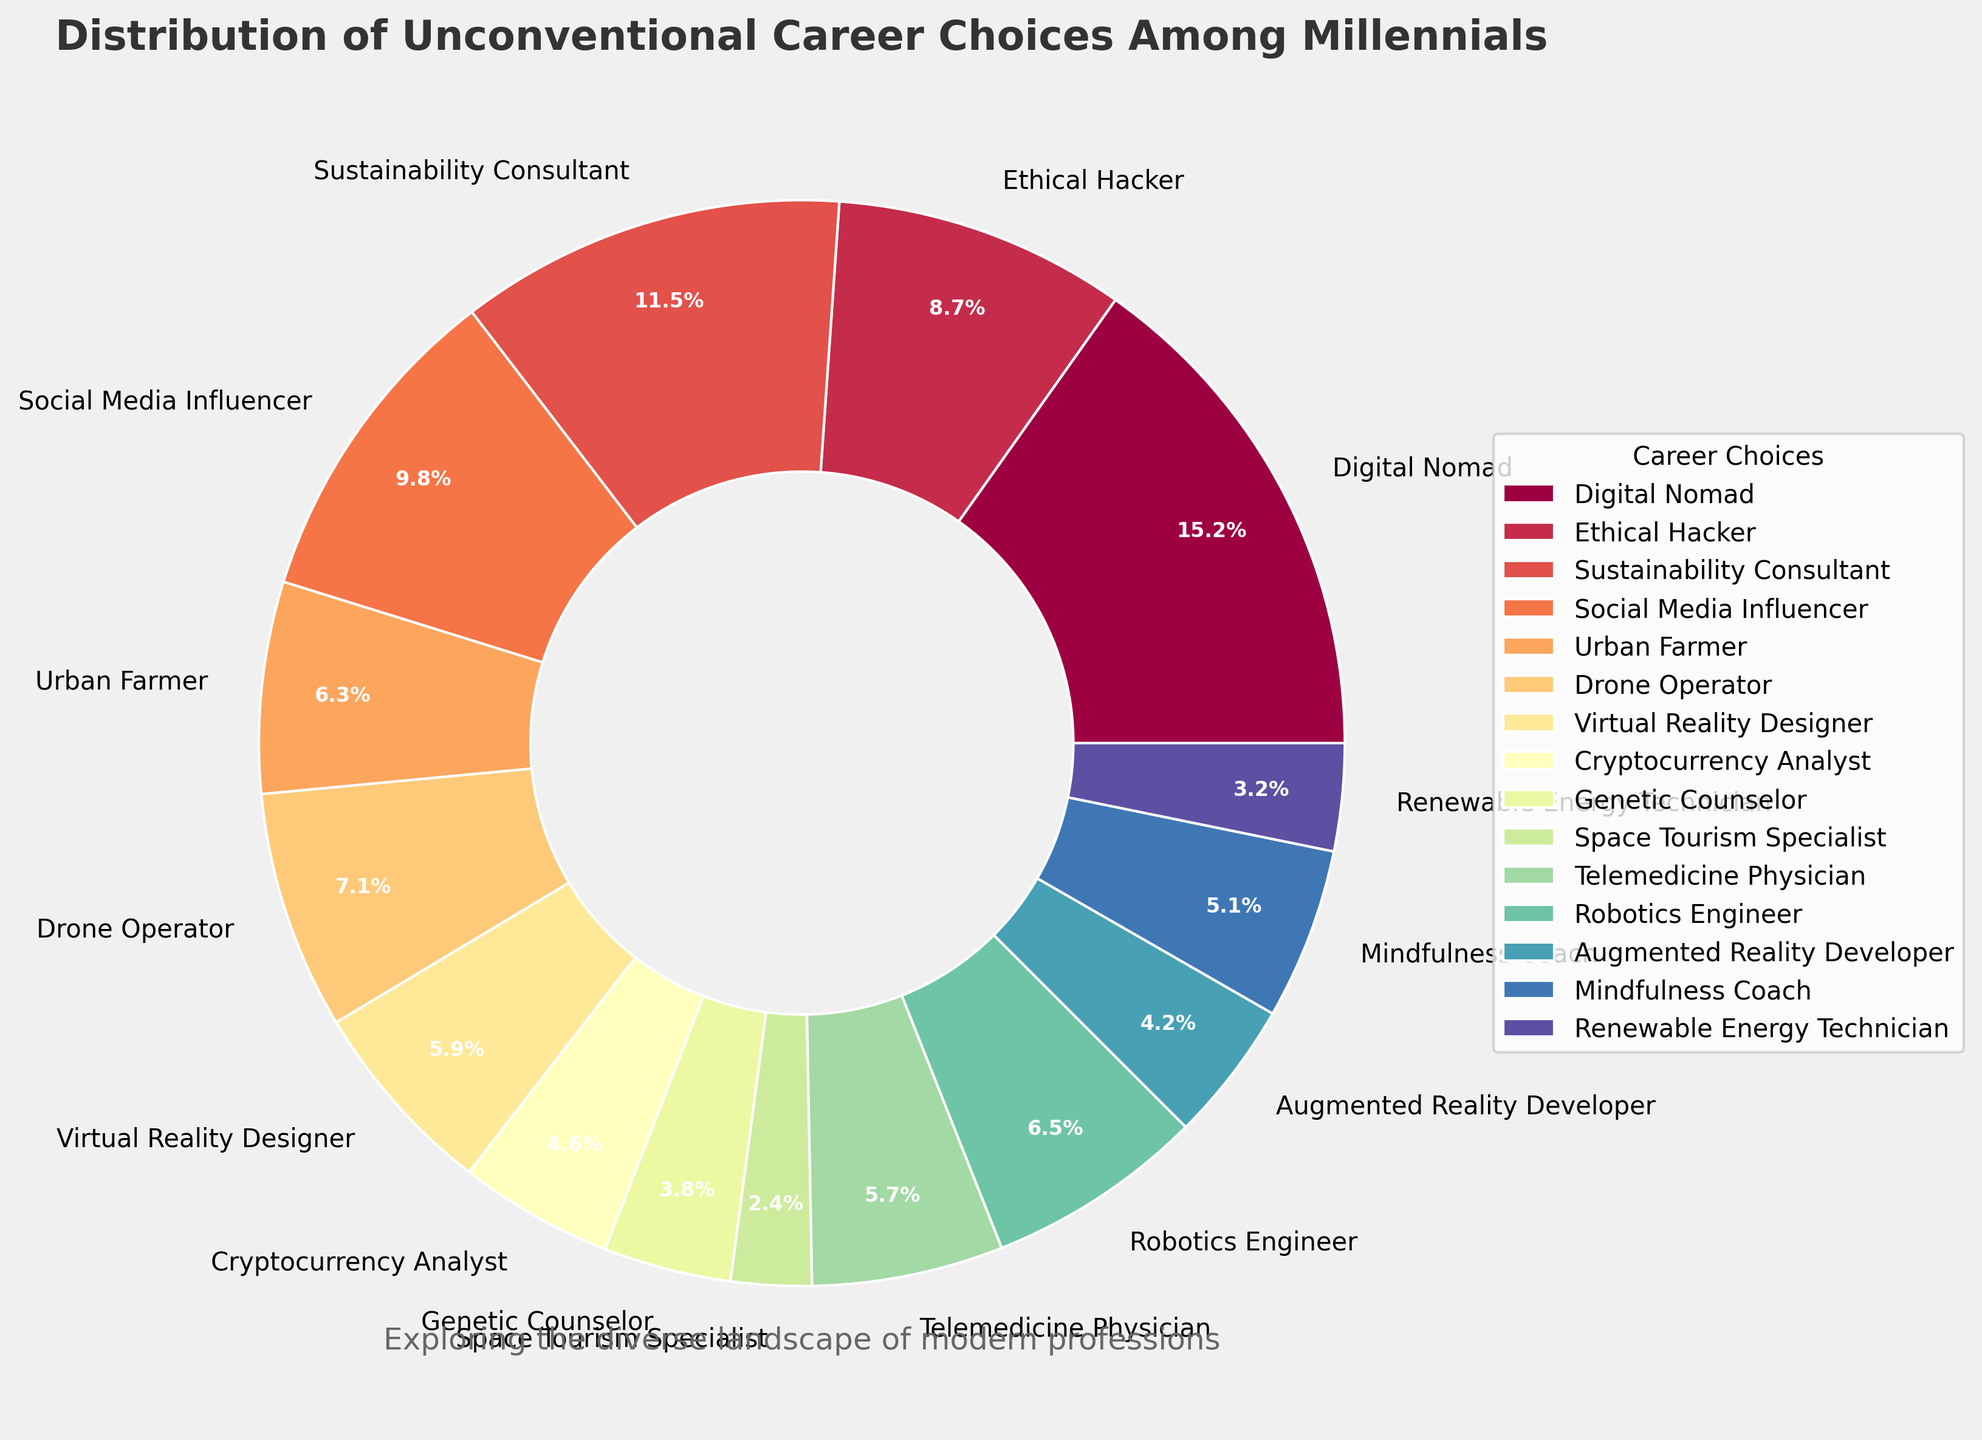Which career has the highest percentage of millennials? The pie chart segments represent the distribution of percentages for the different careers. By looking at the sizes and the labels, we can identify the segment with the largest percentage.
Answer: Digital Nomad How much more popular is being a Digital Nomad compared to a Social Media Influencer? Find the percentages for both careers from the pie chart (Digital Nomad: 15.2%, Social Media Influencer: 9.8%) and subtract the Influencer percentage from the Digital Nomad percentage: 15.2% - 9.8%.
Answer: 5.4% Which career has a slightly higher percentage: Telemedicine Physician or Urban Farmer? Check the pie chart segments for both careers. Telemedicine Physician is 5.7% and Urban Farmer is 6.3%.
Answer: Urban Farmer What is the combined percentage of careers related to technology (Ethical Hacker, Drone Operator, Virtual Reality Designer, Robotics Engineer, Augmented Reality Developer)? Sum the percentages of Ethical Hacker (8.7%), Drone Operator (7.1%), Virtual Reality Designer (5.9%), Robotics Engineer (6.5%), and Augmented Reality Developer (4.2%). The calculation is 8.7% + 7.1% + 5.9% + 6.5% + 4.2%.
Answer: 32.4% What percentage of millennials chose careers that are not technology-related if those are categorized separately (remaining careers)? Subtract the total percentage of technology-related careers (32.4%) from 100%. The calculation is 100% - 32.4%. This gives the percentage of non-tech careers.
Answer: 67.6% What are the least and most common unconventional career choices among millennials? The pie chart shows the percentage distribution of different careers. By comparing the sizes and labels, we can determine that Space Tourism Specialist (2.4%) is the least common and Digital Nomad (15.2%) is the most common.
Answer: Least: Space Tourism Specialist, Most: Digital Nomad 